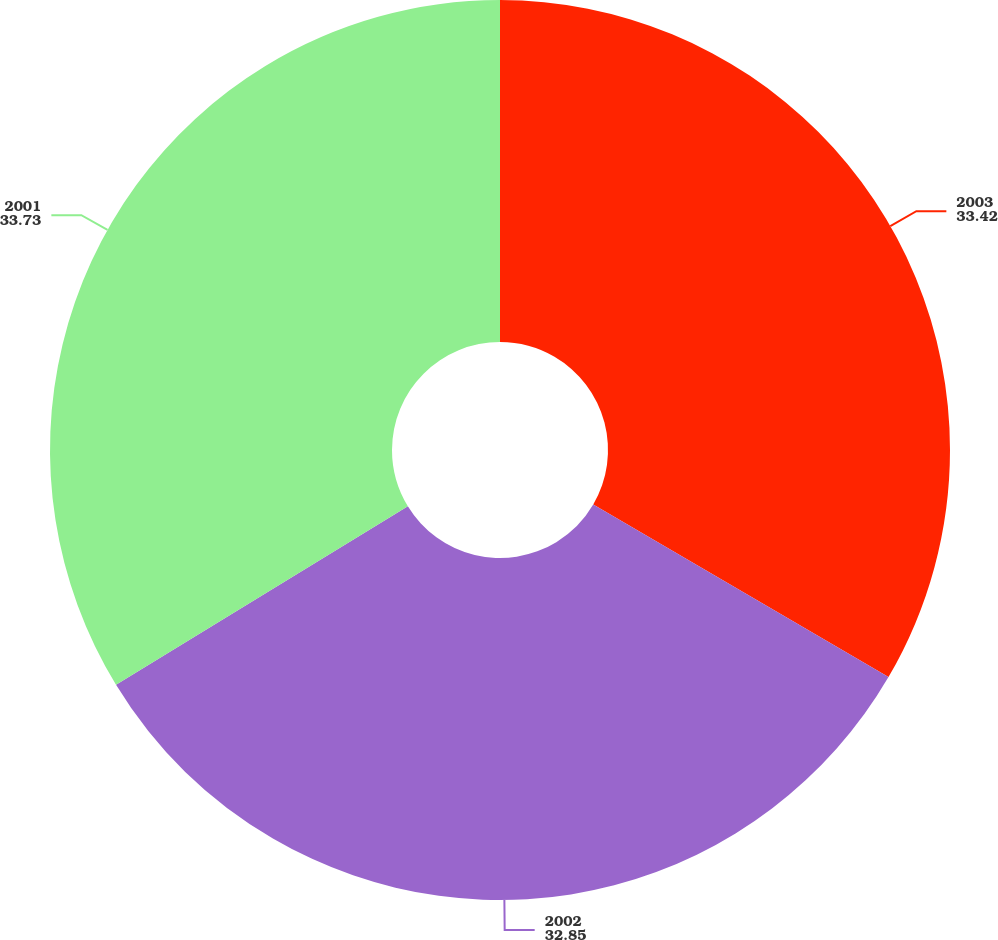Convert chart to OTSL. <chart><loc_0><loc_0><loc_500><loc_500><pie_chart><fcel>2003<fcel>2002<fcel>2001<nl><fcel>33.42%<fcel>32.85%<fcel>33.73%<nl></chart> 